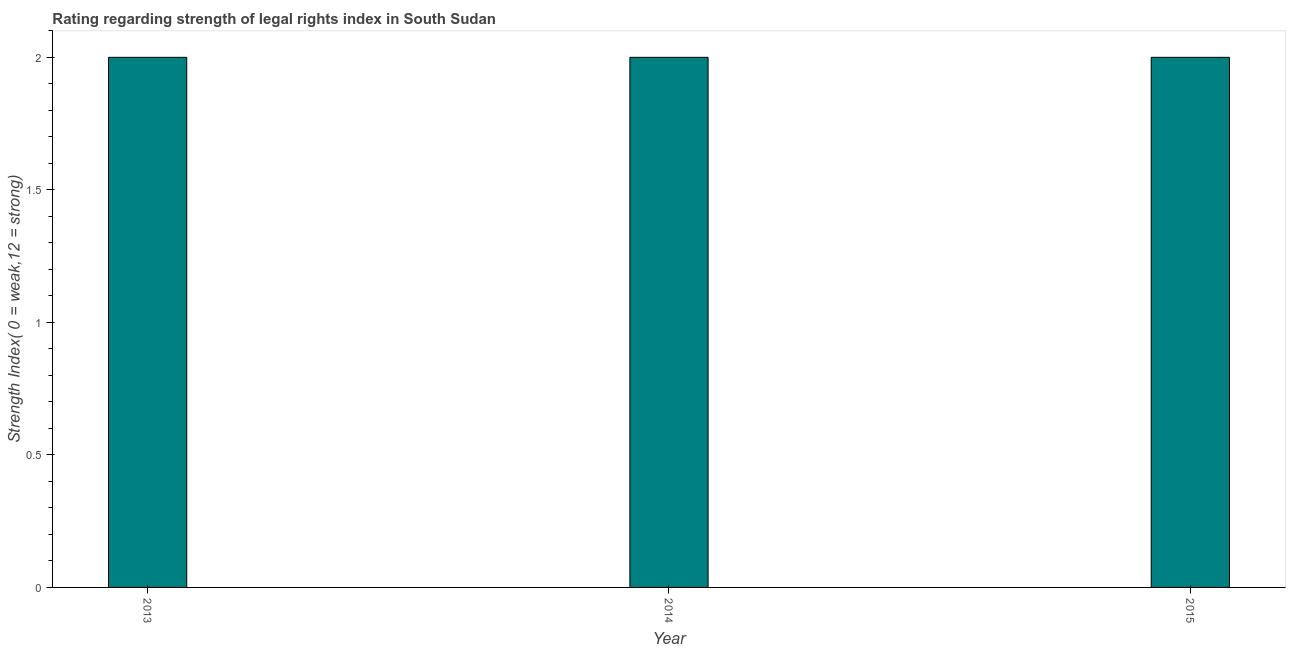What is the title of the graph?
Ensure brevity in your answer.  Rating regarding strength of legal rights index in South Sudan. What is the label or title of the Y-axis?
Your answer should be compact. Strength Index( 0 = weak,12 = strong). Across all years, what is the maximum strength of legal rights index?
Offer a very short reply. 2. In which year was the strength of legal rights index maximum?
Make the answer very short. 2013. What is the median strength of legal rights index?
Give a very brief answer. 2. In how many years, is the strength of legal rights index greater than 0.4 ?
Offer a terse response. 3. Is the strength of legal rights index in 2013 less than that in 2014?
Your response must be concise. No. Is the sum of the strength of legal rights index in 2013 and 2014 greater than the maximum strength of legal rights index across all years?
Offer a terse response. Yes. How many bars are there?
Keep it short and to the point. 3. Are the values on the major ticks of Y-axis written in scientific E-notation?
Make the answer very short. No. What is the Strength Index( 0 = weak,12 = strong) of 2013?
Offer a very short reply. 2. What is the Strength Index( 0 = weak,12 = strong) in 2014?
Offer a very short reply. 2. What is the difference between the Strength Index( 0 = weak,12 = strong) in 2013 and 2014?
Your answer should be very brief. 0. What is the difference between the Strength Index( 0 = weak,12 = strong) in 2014 and 2015?
Make the answer very short. 0. What is the ratio of the Strength Index( 0 = weak,12 = strong) in 2014 to that in 2015?
Provide a short and direct response. 1. 